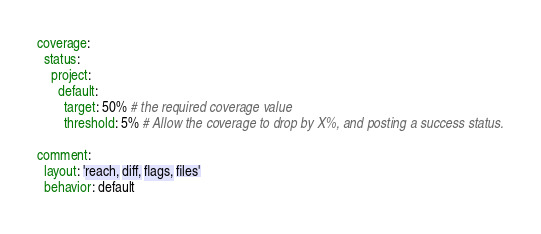<code> <loc_0><loc_0><loc_500><loc_500><_YAML_>coverage:
  status:
    project:
      default:
        target: 50% # the required coverage value
        threshold: 5% # Allow the coverage to drop by X%, and posting a success status.

comment:
  layout: 'reach, diff, flags, files'
  behavior: default
</code> 